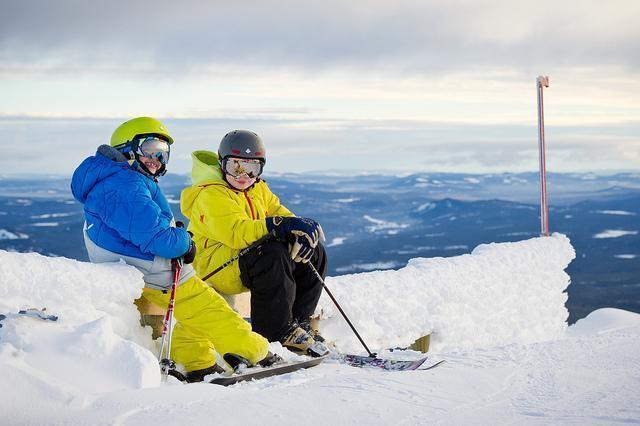What are they doing?
Make your selection from the four choices given to correctly answer the question.
Options: Waiting, eating, arguing, resting. Resting. 